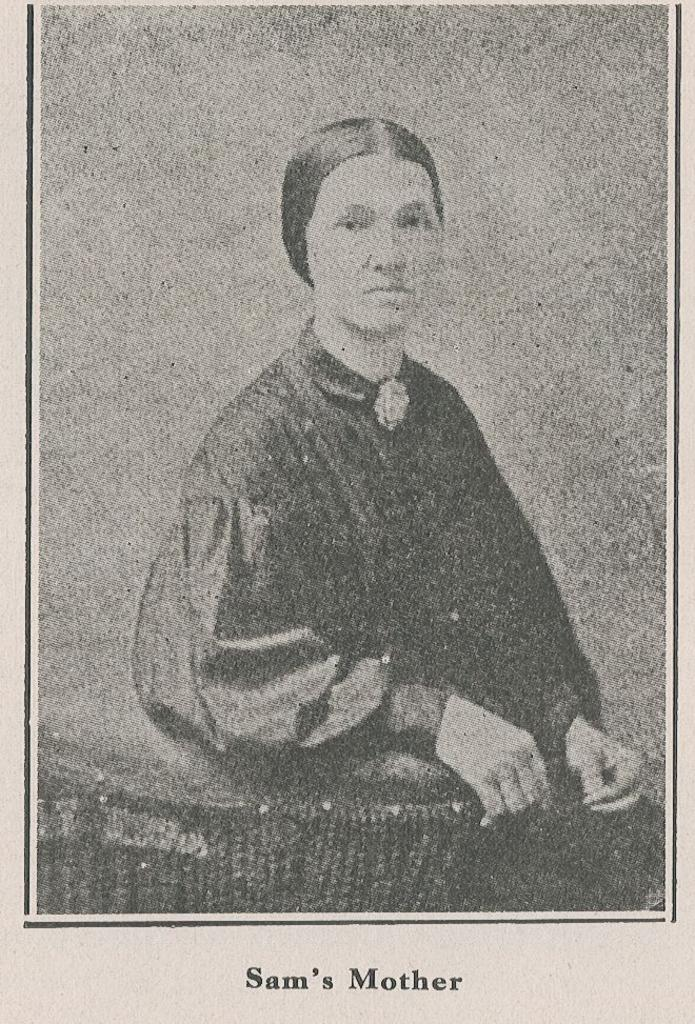What is the main object in the image? There is a paper in the image. What is depicted on the paper? The paper has a photo of a woman on it. What is the woman doing in the photo? The woman is sitting on a chair in the photo. Are there any words or text in the image? Yes, there are words at the bottom of the image. What type of creature can be seen sparking a fire in the image? There is no creature or fire present in the image; it only features a paper with a photo of a woman sitting on a chair and words at the bottom. 